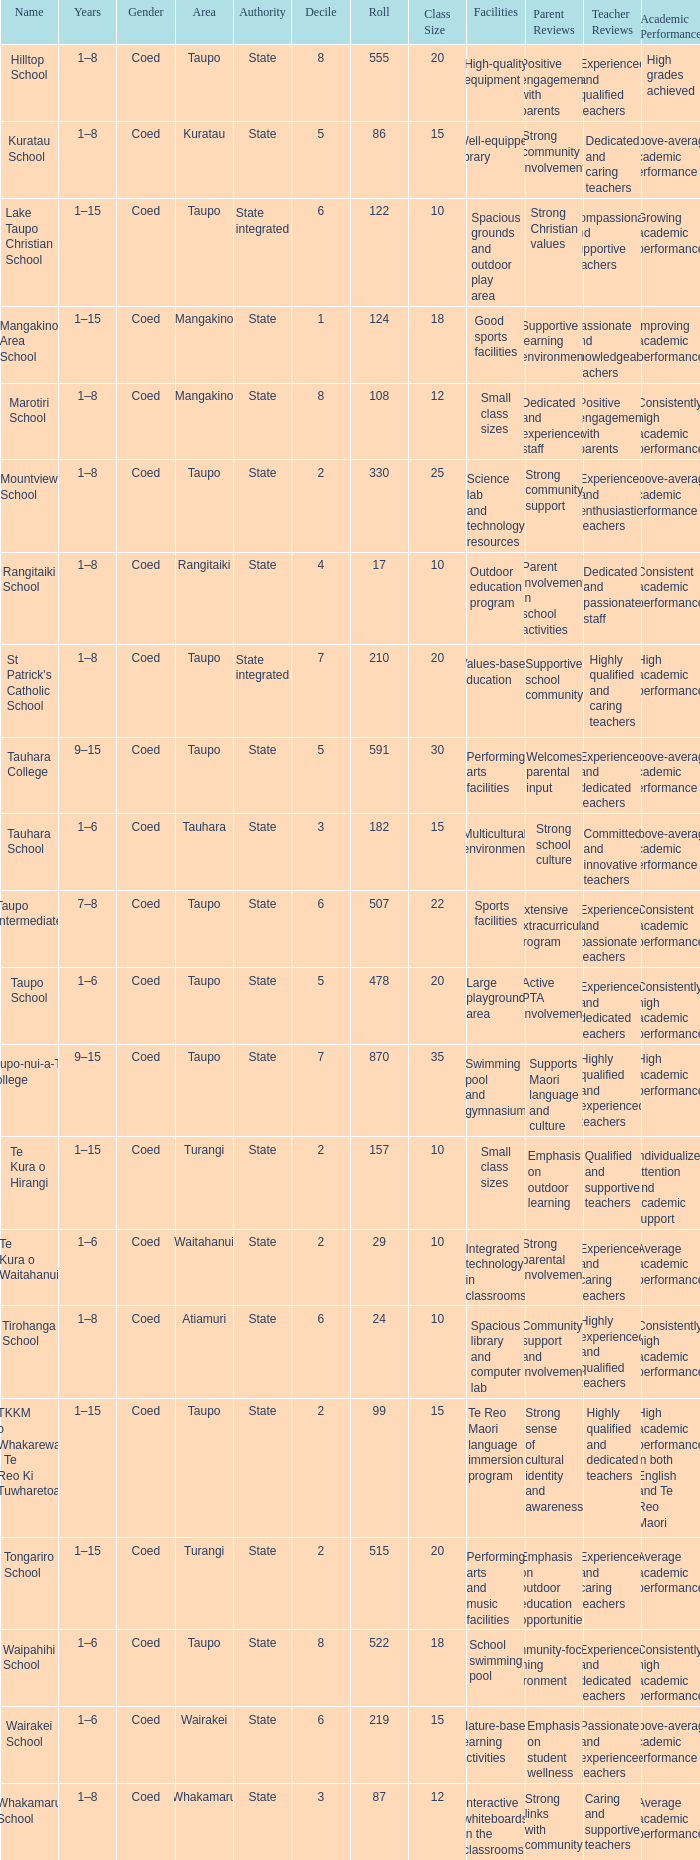What is the Whakamaru school's authority? State. 